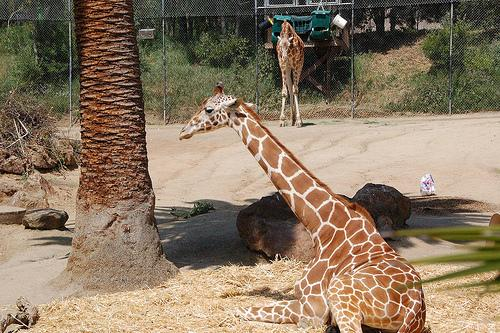What is the primary animal in this image and how does it appear? The primary animal in this image is a giraffe, which appears healthy, tall and attractive with brown spots and a long neck. List three objects present in the image apart from the giraffes. A brown tree trunk, a rock behind the tree, and a pile of brush are present in the image. In the context of this image, comment on the giraffe's behavior or posture. The giraffe is seen laying down, looking to the left, and facing towards the camera, as if it's both relaxed and alert. What is the interaction between the giraffe and a tree in this picture? The giraffe is next to, sitting or laying under the tree, possibly trying to find shade or a comfortable spot to rest.  How can we describe the ground in this image? The ground is dirt with hay, straw grass, and some brown patches of grass. Does the giraffe have any unique physical features? If so, describe it. The giraffe has brown spots over its body with a long neck and an open eye, which makes it appear unique and attentive. 